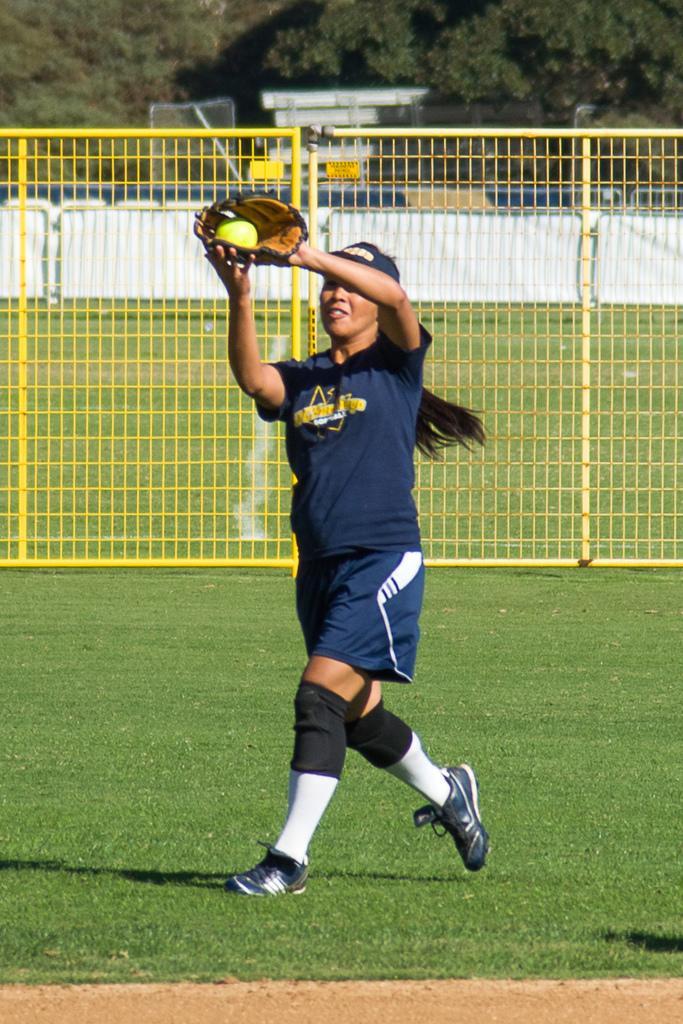Can you describe this image briefly? In this image I can see the person on the ground. The person is wearing the navy blue color jersey and also gloves. In the back I can see the railing, trees and also the white building can be seen. 